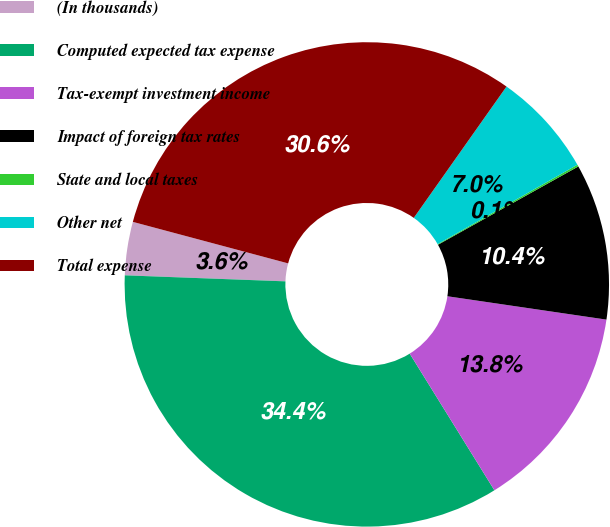Convert chart to OTSL. <chart><loc_0><loc_0><loc_500><loc_500><pie_chart><fcel>(In thousands)<fcel>Computed expected tax expense<fcel>Tax-exempt investment income<fcel>Impact of foreign tax rates<fcel>State and local taxes<fcel>Other net<fcel>Total expense<nl><fcel>3.56%<fcel>34.43%<fcel>13.85%<fcel>10.42%<fcel>0.13%<fcel>6.99%<fcel>30.63%<nl></chart> 